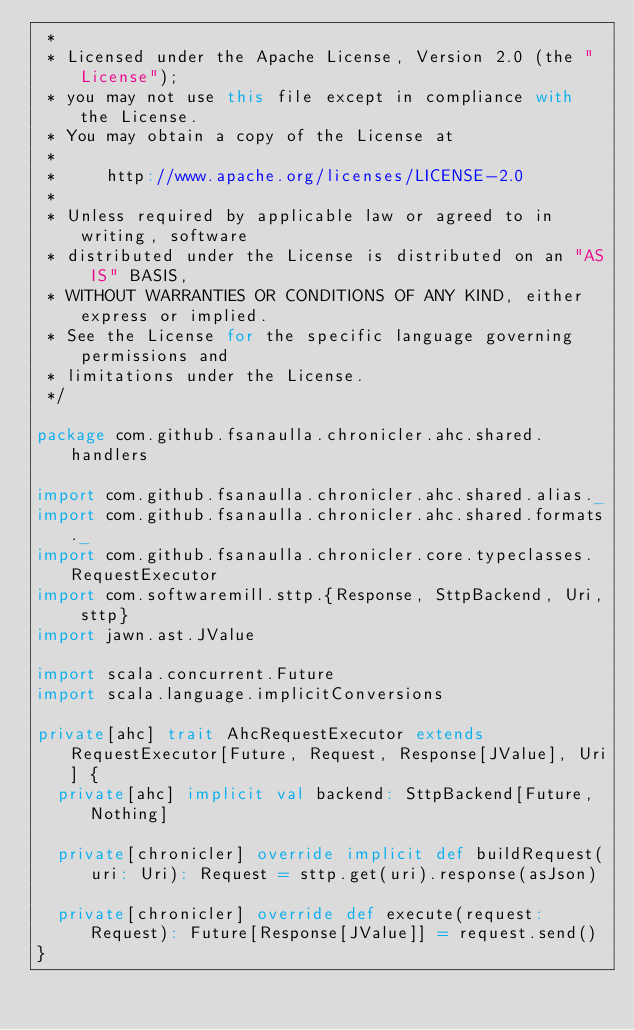<code> <loc_0><loc_0><loc_500><loc_500><_Scala_> *
 * Licensed under the Apache License, Version 2.0 (the "License");
 * you may not use this file except in compliance with the License.
 * You may obtain a copy of the License at
 *
 *     http://www.apache.org/licenses/LICENSE-2.0
 *
 * Unless required by applicable law or agreed to in writing, software
 * distributed under the License is distributed on an "AS IS" BASIS,
 * WITHOUT WARRANTIES OR CONDITIONS OF ANY KIND, either express or implied.
 * See the License for the specific language governing permissions and
 * limitations under the License.
 */

package com.github.fsanaulla.chronicler.ahc.shared.handlers

import com.github.fsanaulla.chronicler.ahc.shared.alias._
import com.github.fsanaulla.chronicler.ahc.shared.formats._
import com.github.fsanaulla.chronicler.core.typeclasses.RequestExecutor
import com.softwaremill.sttp.{Response, SttpBackend, Uri, sttp}
import jawn.ast.JValue

import scala.concurrent.Future
import scala.language.implicitConversions

private[ahc] trait AhcRequestExecutor extends RequestExecutor[Future, Request, Response[JValue], Uri] {
  private[ahc] implicit val backend: SttpBackend[Future, Nothing]

  private[chronicler] override implicit def buildRequest(uri: Uri): Request = sttp.get(uri).response(asJson)

  private[chronicler] override def execute(request: Request): Future[Response[JValue]] = request.send()
}
</code> 